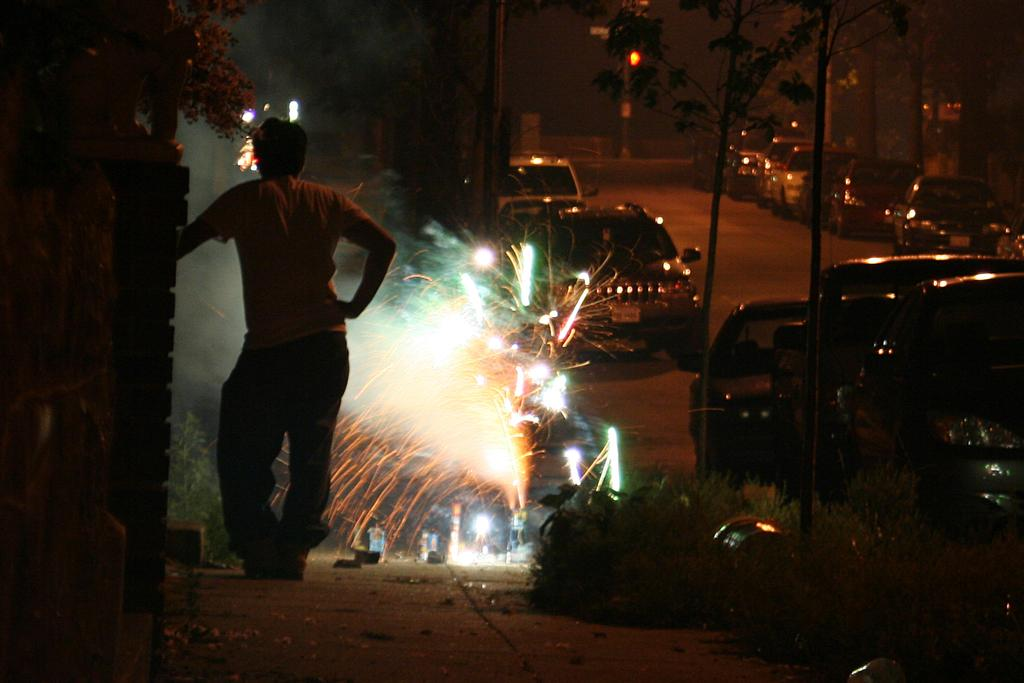What is the main subject in the image? There is a man standing in the image. What type of food can be seen in the image? There are crackers in the image. What can be seen illuminating the scene in the image? There are lights in the image. What is happening on the road in the image? There are vehicles on the road in the image. What type of natural elements are present in the image? There are trees in the image. What type of traffic control device is present in the image? There are traffic lights in the image. What type of cloth is being used to cover the industry in the image? There is no industry or cloth present in the image. What type of stick is being used by the man in the image? There is no stick present in the image; the man is simply standing. 